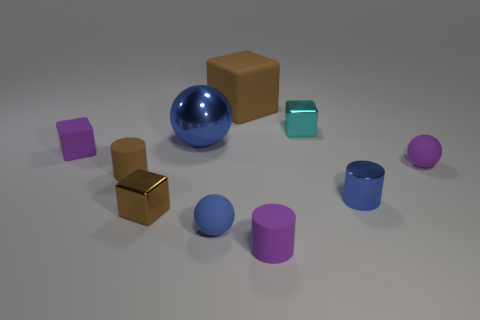Subtract all cubes. How many objects are left? 6 Subtract 0 red blocks. How many objects are left? 10 Subtract all large red blocks. Subtract all small brown blocks. How many objects are left? 9 Add 2 small brown cylinders. How many small brown cylinders are left? 3 Add 5 tiny blue balls. How many tiny blue balls exist? 6 